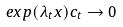Convert formula to latex. <formula><loc_0><loc_0><loc_500><loc_500>e x p ( \lambda _ { t } x ) c _ { t } \rightarrow 0</formula> 